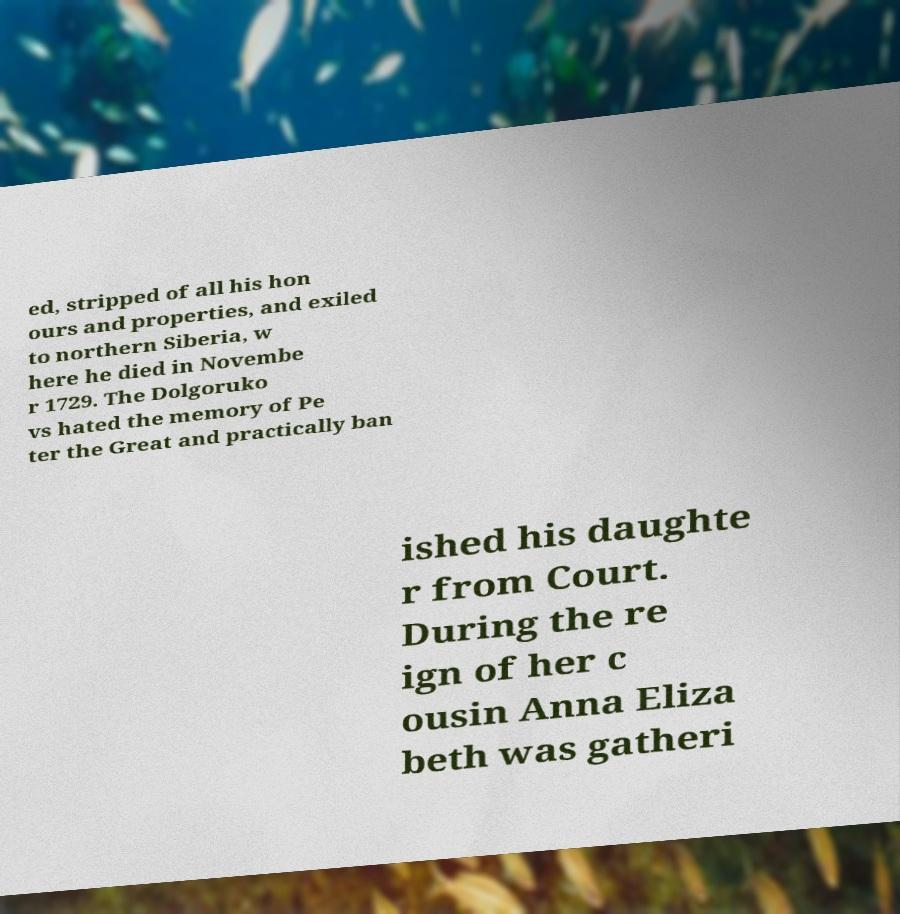Could you assist in decoding the text presented in this image and type it out clearly? ed, stripped of all his hon ours and properties, and exiled to northern Siberia, w here he died in Novembe r 1729. The Dolgoruko vs hated the memory of Pe ter the Great and practically ban ished his daughte r from Court. During the re ign of her c ousin Anna Eliza beth was gatheri 